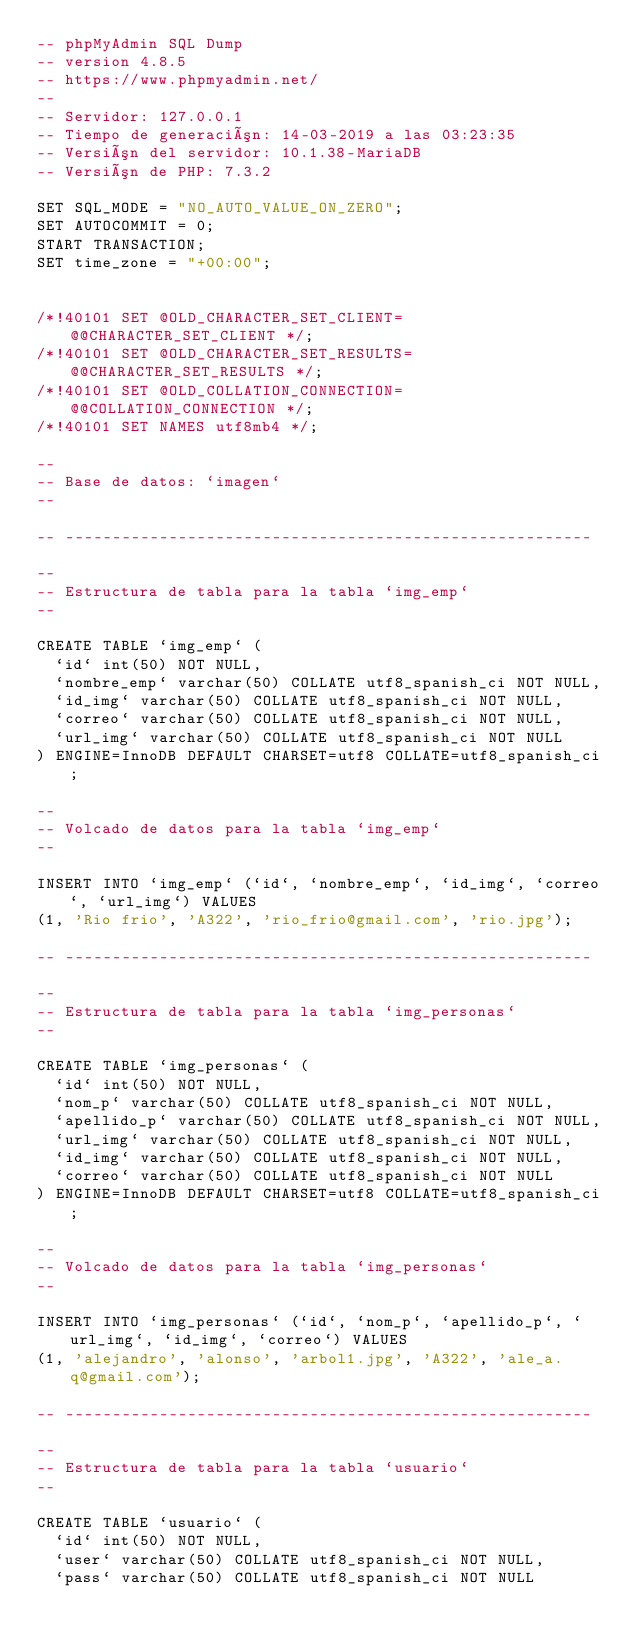<code> <loc_0><loc_0><loc_500><loc_500><_SQL_>-- phpMyAdmin SQL Dump
-- version 4.8.5
-- https://www.phpmyadmin.net/
--
-- Servidor: 127.0.0.1
-- Tiempo de generación: 14-03-2019 a las 03:23:35
-- Versión del servidor: 10.1.38-MariaDB
-- Versión de PHP: 7.3.2

SET SQL_MODE = "NO_AUTO_VALUE_ON_ZERO";
SET AUTOCOMMIT = 0;
START TRANSACTION;
SET time_zone = "+00:00";


/*!40101 SET @OLD_CHARACTER_SET_CLIENT=@@CHARACTER_SET_CLIENT */;
/*!40101 SET @OLD_CHARACTER_SET_RESULTS=@@CHARACTER_SET_RESULTS */;
/*!40101 SET @OLD_COLLATION_CONNECTION=@@COLLATION_CONNECTION */;
/*!40101 SET NAMES utf8mb4 */;

--
-- Base de datos: `imagen`
--

-- --------------------------------------------------------

--
-- Estructura de tabla para la tabla `img_emp`
--

CREATE TABLE `img_emp` (
  `id` int(50) NOT NULL,
  `nombre_emp` varchar(50) COLLATE utf8_spanish_ci NOT NULL,
  `id_img` varchar(50) COLLATE utf8_spanish_ci NOT NULL,
  `correo` varchar(50) COLLATE utf8_spanish_ci NOT NULL,
  `url_img` varchar(50) COLLATE utf8_spanish_ci NOT NULL
) ENGINE=InnoDB DEFAULT CHARSET=utf8 COLLATE=utf8_spanish_ci;

--
-- Volcado de datos para la tabla `img_emp`
--

INSERT INTO `img_emp` (`id`, `nombre_emp`, `id_img`, `correo`, `url_img`) VALUES
(1, 'Rio frio', 'A322', 'rio_frio@gmail.com', 'rio.jpg');

-- --------------------------------------------------------

--
-- Estructura de tabla para la tabla `img_personas`
--

CREATE TABLE `img_personas` (
  `id` int(50) NOT NULL,
  `nom_p` varchar(50) COLLATE utf8_spanish_ci NOT NULL,
  `apellido_p` varchar(50) COLLATE utf8_spanish_ci NOT NULL,
  `url_img` varchar(50) COLLATE utf8_spanish_ci NOT NULL,
  `id_img` varchar(50) COLLATE utf8_spanish_ci NOT NULL,
  `correo` varchar(50) COLLATE utf8_spanish_ci NOT NULL
) ENGINE=InnoDB DEFAULT CHARSET=utf8 COLLATE=utf8_spanish_ci;

--
-- Volcado de datos para la tabla `img_personas`
--

INSERT INTO `img_personas` (`id`, `nom_p`, `apellido_p`, `url_img`, `id_img`, `correo`) VALUES
(1, 'alejandro', 'alonso', 'arbol1.jpg', 'A322', 'ale_a.q@gmail.com');

-- --------------------------------------------------------

--
-- Estructura de tabla para la tabla `usuario`
--

CREATE TABLE `usuario` (
  `id` int(50) NOT NULL,
  `user` varchar(50) COLLATE utf8_spanish_ci NOT NULL,
  `pass` varchar(50) COLLATE utf8_spanish_ci NOT NULL</code> 